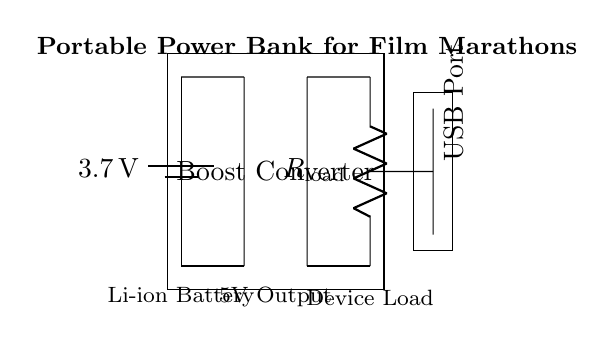What is the voltage of the battery? The circuit shows a battery with a labeled voltage of 3.7V. The distinction between the battery and other components is crucial to identify the source voltage.
Answer: 3.7V What type of converter is used in this circuit? The diagram depicts a "Boost Converter" as indicated in the rectangular annotation within the circuit. The context of its use suggests it's stepping up the voltage for output.
Answer: Boost Converter What is the output voltage after the boost converter? According to the labeled section of the circuit, the output voltage is specified as 5V following the boost converter, which is needed to charge USB devices.
Answer: 5V Which component represents the load in the circuit? The circuit clearly shows a resistor labeled "R load," indicating it simulates the device load connected to the power bank. Understanding this helps identify how load affects current usage.
Answer: R load What type of port is provided for charging devices? The circuit diagram includes a "USB Port" which is essential for connecting portable devices for charging. The designation indicates compatibility with standard charging cables.
Answer: USB Port What is the purpose of this circuit? The overall design is identified as a "Portable Power Bank for Film Marathons," suggesting an intention to supply power during extended use of devices, especially for watching films.
Answer: Power Bank for Film Marathons 